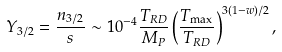<formula> <loc_0><loc_0><loc_500><loc_500>Y _ { 3 / 2 } = \frac { n _ { 3 / 2 } } { s } \sim 1 0 ^ { - 4 } \frac { T _ { R D } } { M _ { P } } \left ( \frac { T _ { \max } } { T _ { R D } } \right ) ^ { 3 ( 1 - w ) / 2 } ,</formula> 